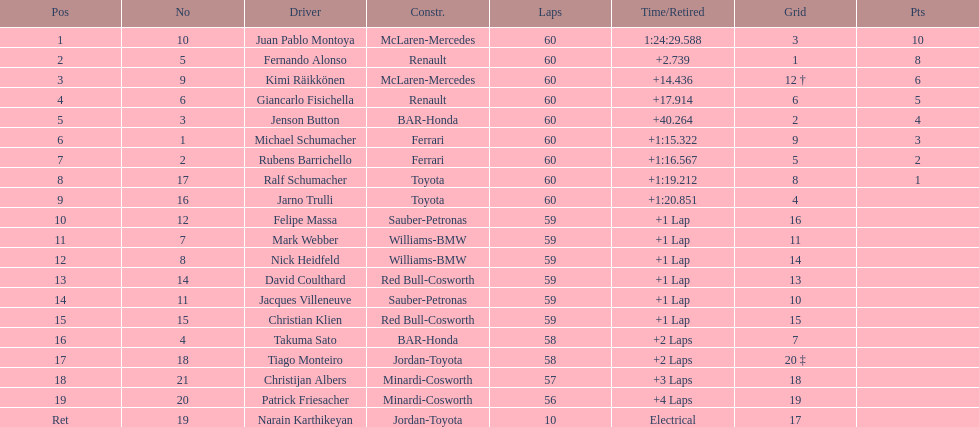Which driver in the top 8, drives a mclaran-mercedes but is not in first place? Kimi Räikkönen. 